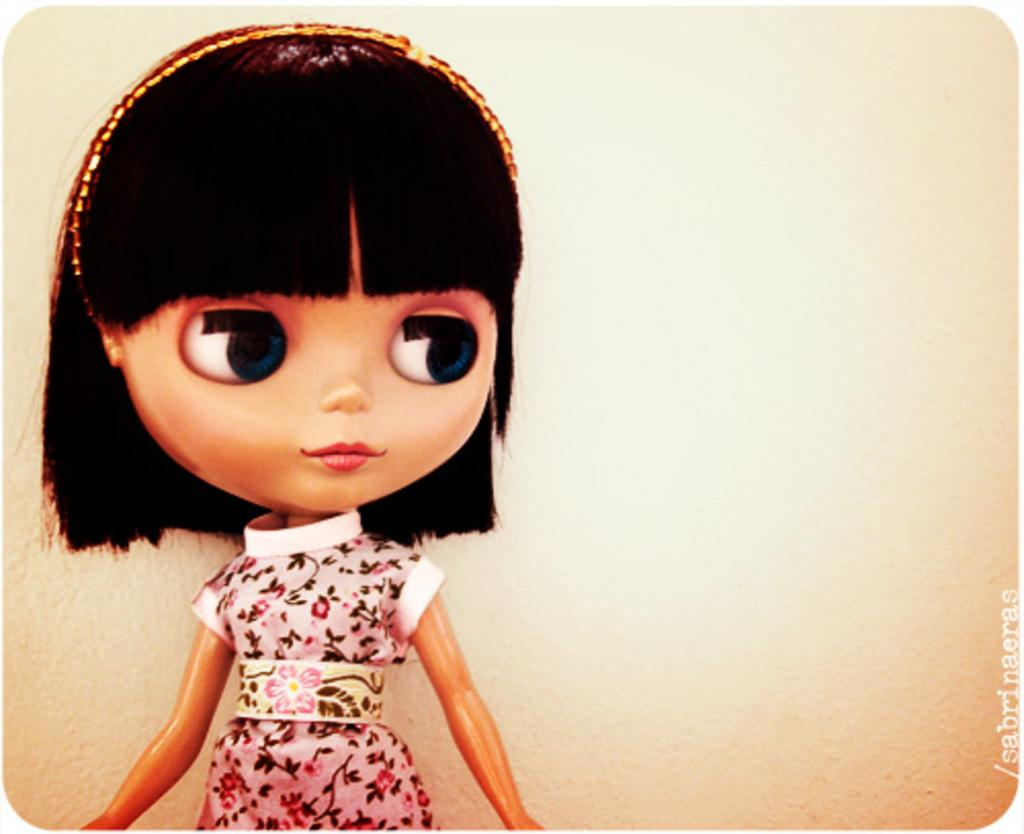What is the main subject of the image? There is a toy of a girl in the image. What can be seen in the background of the image? There is a wall in the background of the image. What scientific experiment is being conducted in the image? There is no scientific experiment present in the image; it features a toy of a girl and a wall in the background. 